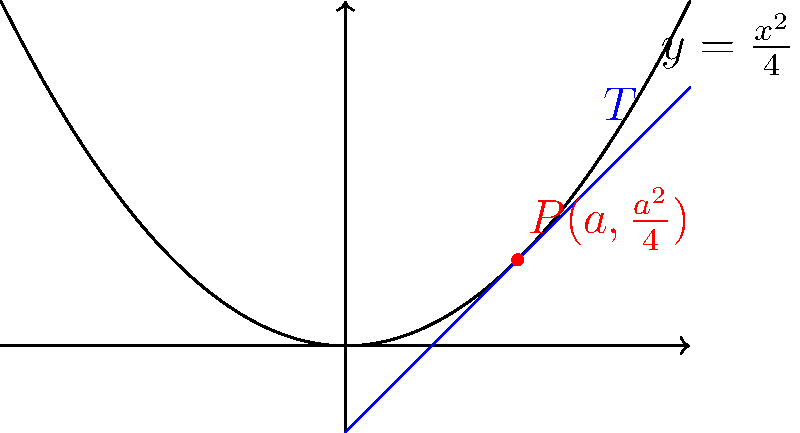As a business lawyer, you often encounter cases involving mathematical modeling. Consider a parabola given by the equation $y = \frac{x^2}{4}$. A tangent line $T$ is drawn to this parabola at the point $P(a,\frac{a^2}{4})$, where $a > 0$. What is the y-intercept of this tangent line in terms of $a$? Let's approach this step-by-step:

1) The slope of the tangent line at any point $(x,y)$ on the parabola $y = \frac{x^2}{4}$ is given by the derivative:

   $m = \frac{dy}{dx} = \frac{x}{2}$

2) At the point $P(a,\frac{a^2}{4})$, the slope of the tangent line is:

   $m = \frac{a}{2}$

3) We can use the point-slope form of a line to write the equation of the tangent line:

   $y - y_1 = m(x - x_1)$

   Where $(x_1,y_1)$ is the point of tangency $P(a,\frac{a^2}{4})$

4) Substituting the values:

   $y - \frac{a^2}{4} = \frac{a}{2}(x - a)$

5) To find the y-intercept, we set $x = 0$ and solve for $y$:

   $y - \frac{a^2}{4} = \frac{a}{2}(0 - a)$
   $y - \frac{a^2}{4} = -\frac{a^2}{2}$
   $y = \frac{a^2}{4} - \frac{a^2}{2} = -\frac{a^2}{4}$

6) Therefore, the y-intercept of the tangent line is $-\frac{a^2}{4}$.
Answer: $-\frac{a^2}{4}$ 